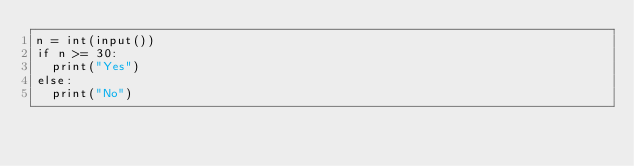<code> <loc_0><loc_0><loc_500><loc_500><_Python_>n = int(input())
if n >= 30:
  print("Yes")
else:
  print("No")</code> 